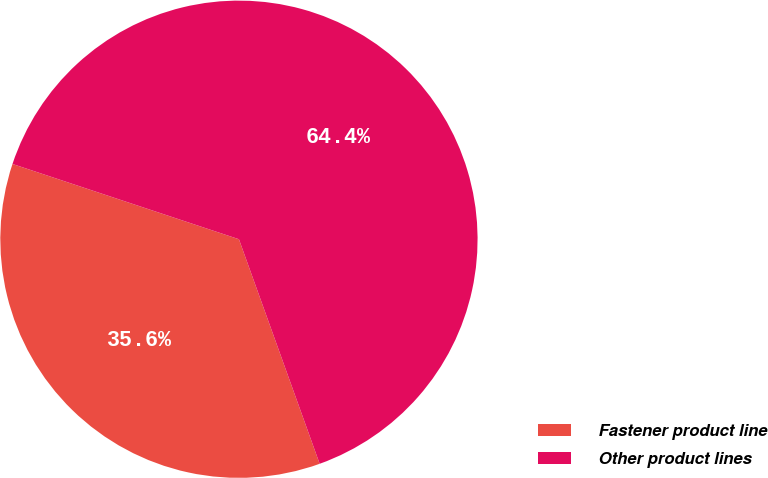<chart> <loc_0><loc_0><loc_500><loc_500><pie_chart><fcel>Fastener product line<fcel>Other product lines<nl><fcel>35.6%<fcel>64.4%<nl></chart> 